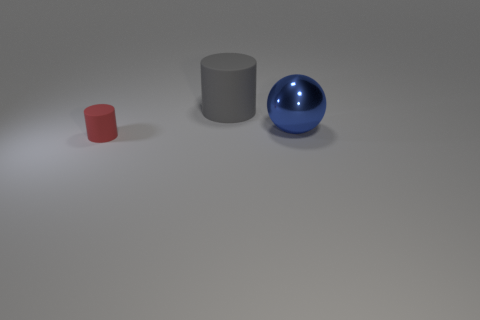Are there any other things that are the same size as the red matte object?
Your response must be concise. No. Is there any other thing that has the same material as the large ball?
Offer a terse response. No. Are there more big gray matte things that are on the left side of the large blue metal ball than gray matte blocks?
Your answer should be very brief. Yes. There is a large thing in front of the matte cylinder behind the tiny red rubber thing; how many large shiny balls are in front of it?
Offer a very short reply. 0. There is a matte thing right of the red matte cylinder; is its size the same as the rubber object that is in front of the blue sphere?
Provide a succinct answer. No. What is the sphere that is in front of the rubber object on the right side of the small matte object made of?
Ensure brevity in your answer.  Metal. What number of objects are things behind the tiny red rubber cylinder or small red cylinders?
Make the answer very short. 3. Are there the same number of big metallic objects on the right side of the large ball and blue spheres that are left of the gray rubber object?
Your response must be concise. Yes. What material is the cylinder that is behind the rubber object that is in front of the matte thing behind the small red thing?
Keep it short and to the point. Rubber. There is a thing that is both right of the small matte object and on the left side of the large blue thing; what size is it?
Your answer should be very brief. Large. 